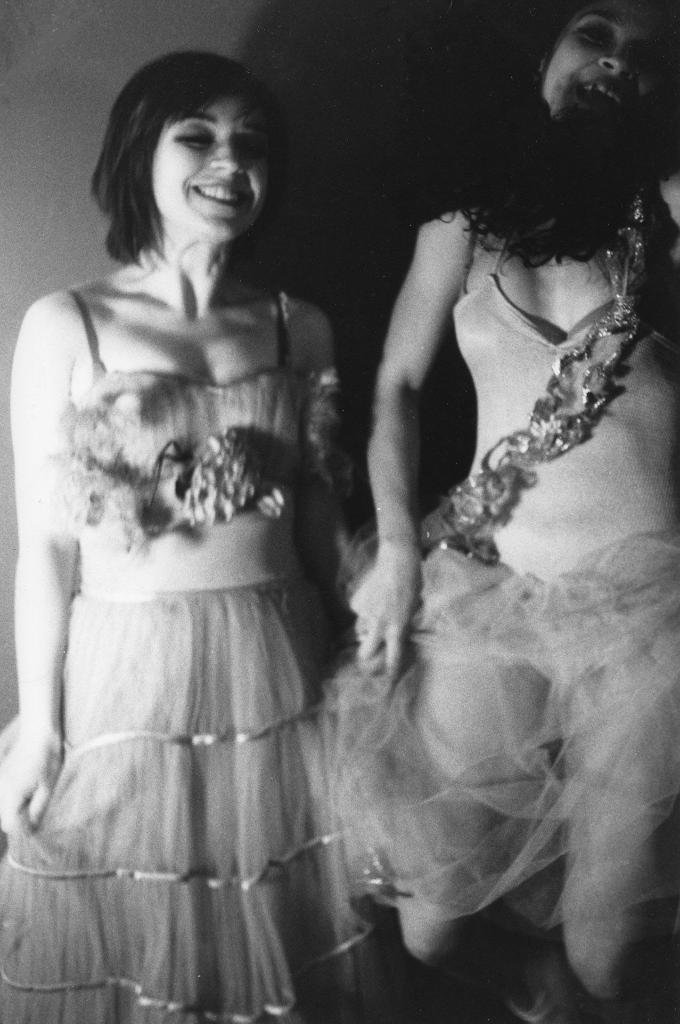What is the color scheme of the image? The picture is in black and white. How many people are in the image? There are two women in the image. What are the women wearing? The women are wearing frocks. What team do the women support in the image? There is no indication of a team or any sports-related activity in the image. 